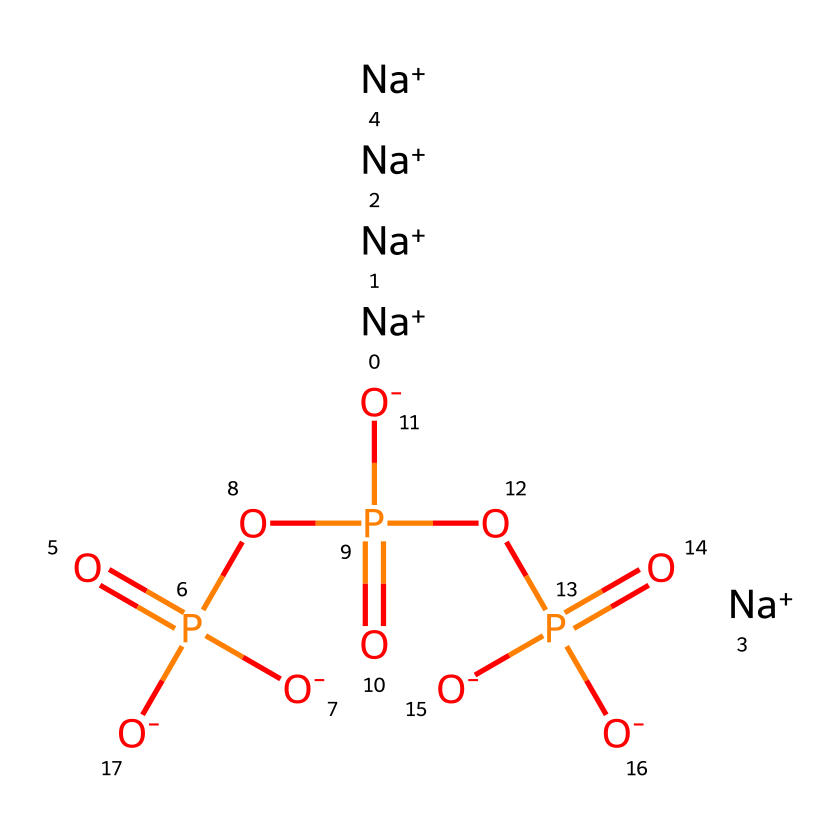What is the molecular formula of sodium tripolyphosphate? The SMILES representation indicates the presence of sodium (Na), phosphorus (P), and oxygen (O). Counting the atoms represented in the structure, there are 5 sodium atoms, 3 phosphorus atoms, and 10 oxygen atoms, leading to the formula Na5P3O10.
Answer: Na5P3O10 How many phosphorus atoms are in sodium tripolyphosphate? By analyzing the structure, it can be seen that there are 3 phosphorus (P) atoms indicated in the chemical representation.
Answer: 3 What type of functional groups are present in sodium tripolyphosphate? The chemical contains phosphate groups, characterized by the presence of phosphate (PO4) in the structure. The repetitive phosphate units signify its function as a phosphate ester.
Answer: phosphate groups How many sodium ions are represented in the structure of sodium tripolyphosphate? The SMILES representation shows that there are 5 sodium (Na) ions, as indicated by the notation for sodium ions (Na+) repeated five times.
Answer: 5 What is the total number of oxygen atoms in sodium tripolyphosphate? Counting the oxygen (O) atoms in the structure shows that there are 10 oxygen atoms present, as indicated in the chemical representation.
Answer: 10 Does sodium tripolyphosphate contain any double bonds? The structure shows that the phosphorus atoms are bonded to oxygen (O) atoms with single bonds, alongside some double bonds (as seen in the P=O), but overall there are no double bonds directly connecting the sodium to phosphorus or oxygen.
Answer: yes What kind of interactions does sodium tripolyphosphate facilitate due to its composition? The presence of multiple phosphate groups allows the compound to engage in complexation with metal ions and can also act as a chelating agent, thus facilitating ion exchange and softening function in certain applications.
Answer: complexation 